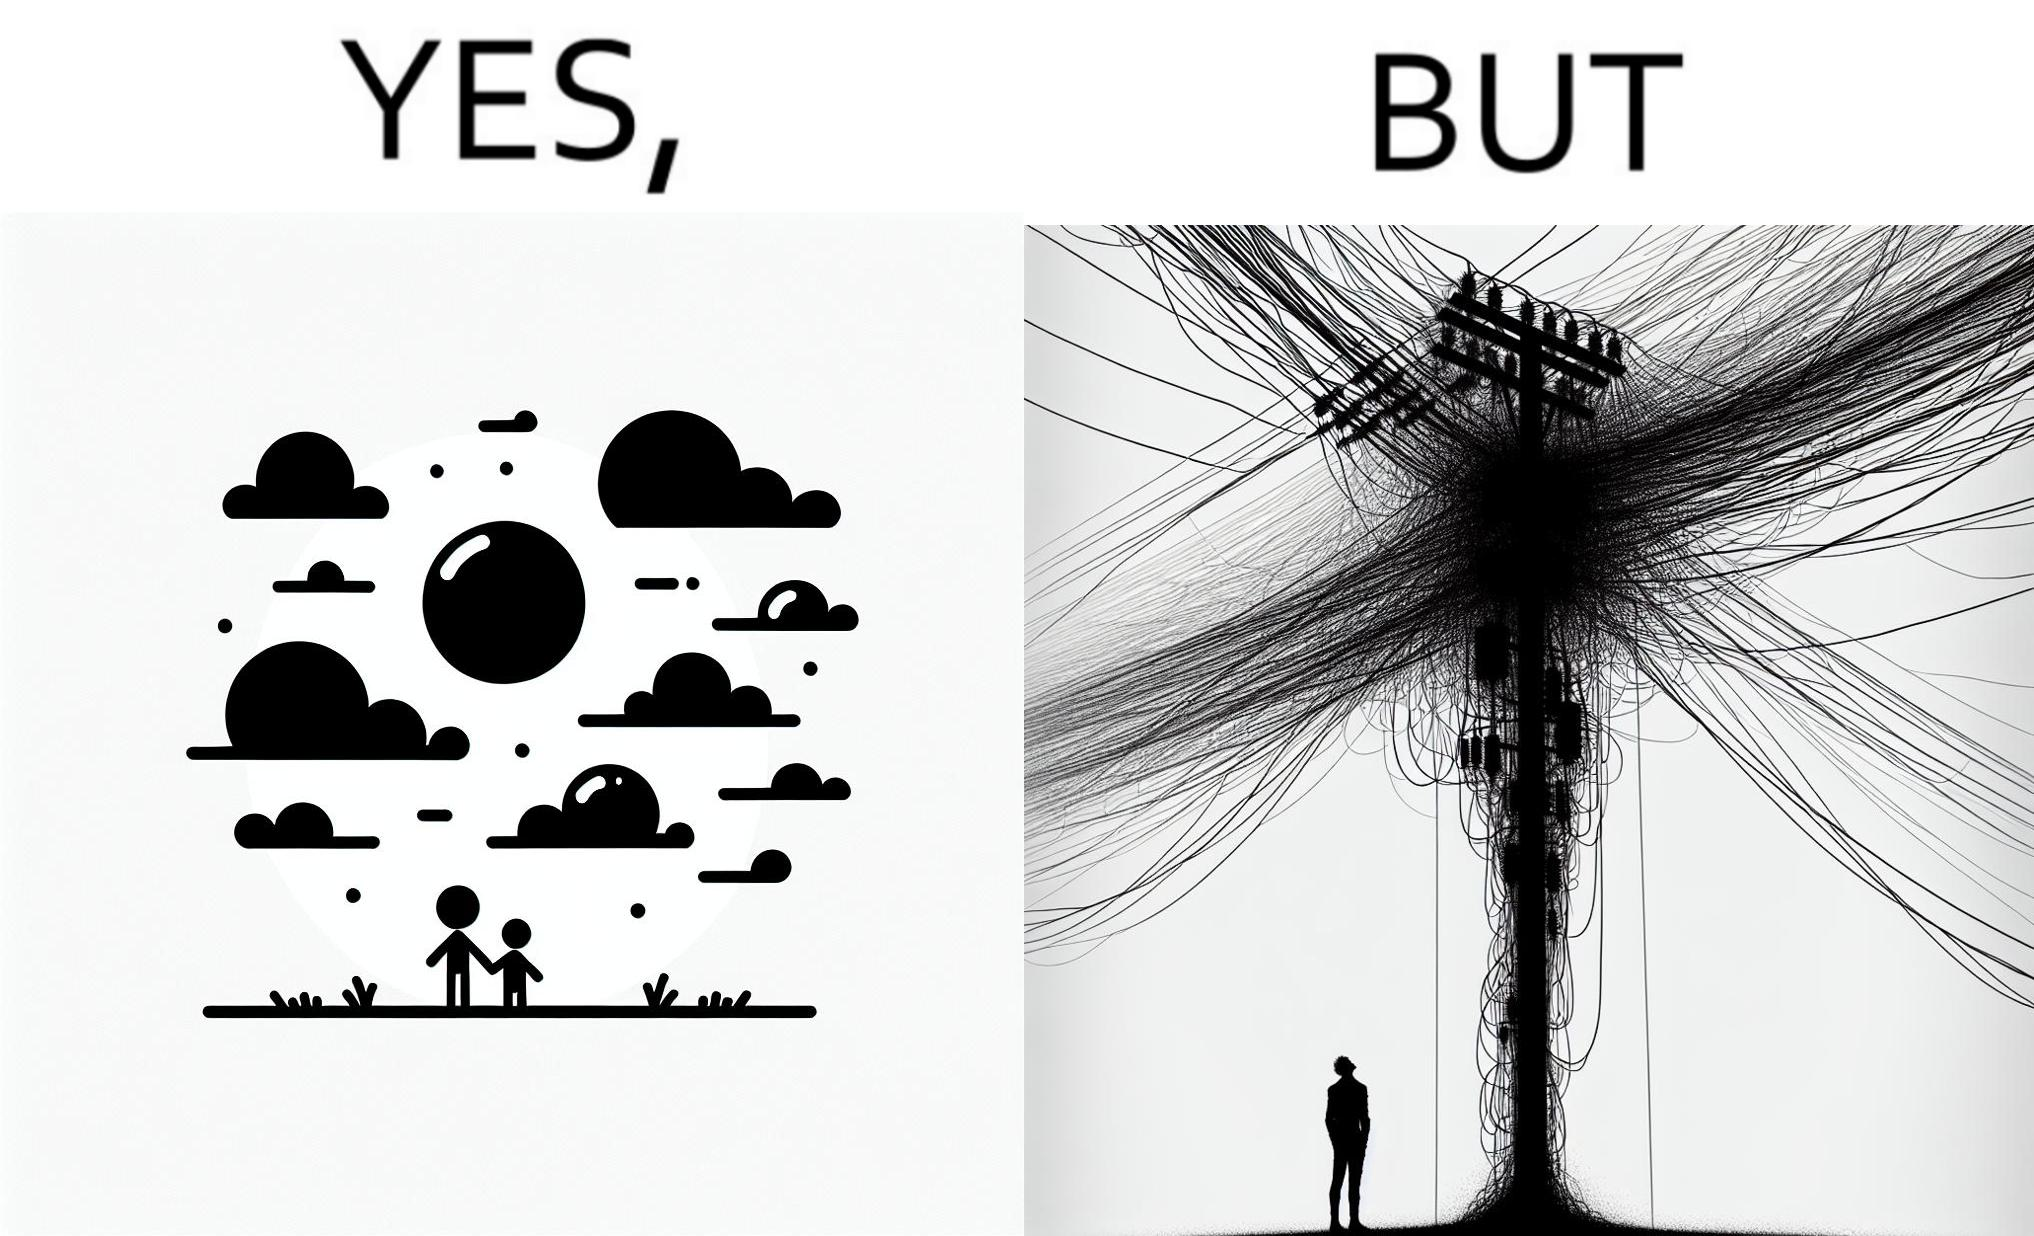Describe the contrast between the left and right parts of this image. In the left part of the image: a clear sky with sun and clouds In the right part of the image: an electricity pole with a lot of wires over it 